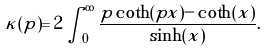<formula> <loc_0><loc_0><loc_500><loc_500>\kappa ( p ) = 2 \int _ { 0 } ^ { \infty } \frac { p \coth ( p x ) - \coth ( x ) } { \sinh ( x ) } .</formula> 